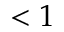<formula> <loc_0><loc_0><loc_500><loc_500>< 1</formula> 